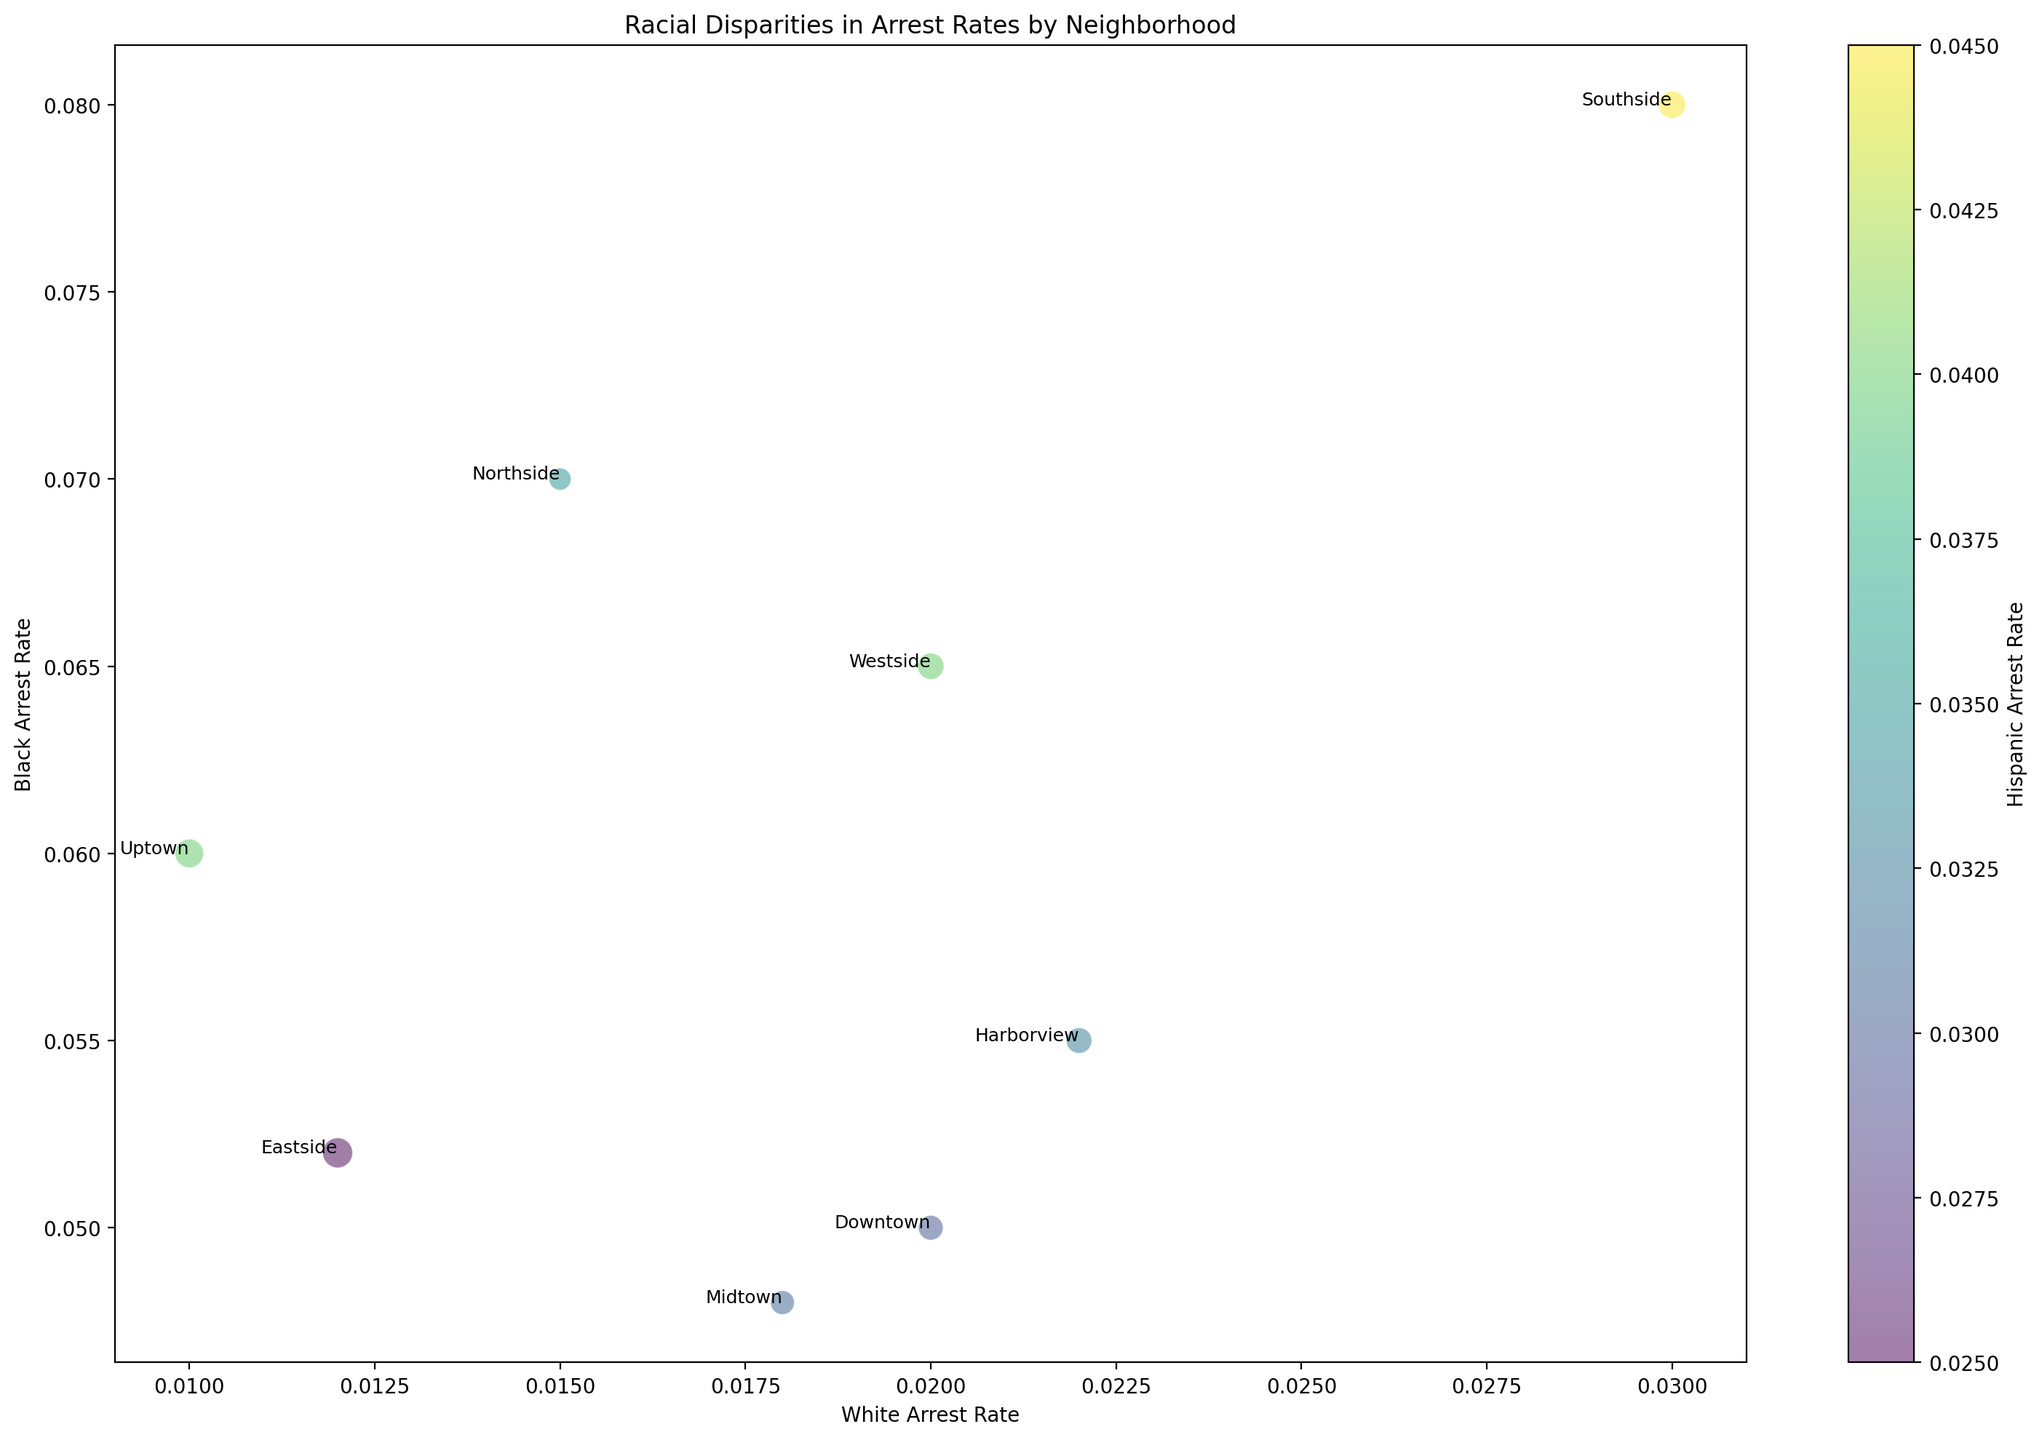Which neighborhood has the highest Black arrest rate? By observing the y-axis values representing the Black arrest rates, Southside has the highest y-value, indicating it has the highest Black arrest rate.
Answer: Southside Which neighborhood has the lowest White arrest rate? By examining the x-axis values representing the White arrest rates, Uptown has the lowest x-value, indicating it has the lowest White arrest rate.
Answer: Uptown Which neighborhood has a higher Hispanic arrest rate, Northside or Harborview? To determine this, look at the color intensity of the bubbles representing Northside and Harborview. Northside's bubble is darker (higher rate) compared to Harborview.
Answer: Northside What is the ratio of the Black arrest rate to the White arrest rate in Downtown? Find Downtown's values on the figure: White Arrest Rate is 0.02 and Black Arrest Rate is 0.05. The ratio is 0.05 / 0.02 = 2.5.
Answer: 2.5 Between Eastside and Westside, which neighborhood has a greater population size? Population size is represented by the size of the bubbles. Eastside's bubble is larger than Westside's, indicating a greater population size.
Answer: Eastside Which neighborhood has the closest arrest rates for White and Black populations? Compare both arrest rates for each neighborhood. Midtown (White: 0.018, Black: 0.048) has the smallest difference of 0.03.
Answer: Midtown Is there a trend between the Hispanic arrest rate and the population size of neighborhoods? To identify trends, observe bubble sizes (population) and the color gradient (Hispanic arrest rate). Larger bubbles (higher populations) do not consistently match the color gradient, indicating no clear trend.
Answer: No clear trend How does Southside’s White arrest rate compare to Harborview’s? Compare x-axis values for Southside (0.03) and Harborview (0.022). Southside's White arrest rate is higher.
Answer: Southside What is the average Black arrest rate for neighborhoods with a White arrest rate below 0.02? Identify neighborhoods with White arrest rates below 0.02 (Uptown, Northside, Eastside). Average Black arrest rates: (0.06 + 0.07 + 0.052) / 3 = 0.0607.
Answer: 0.0607 Which two neighborhoods have the most similar Black arrest rate, and what is it? Compare y-axis values for similarity. Downtown (0.05) and Eastside (0.052) are closest, each around 0.05.
Answer: Downtown and Eastside at ~0.05 